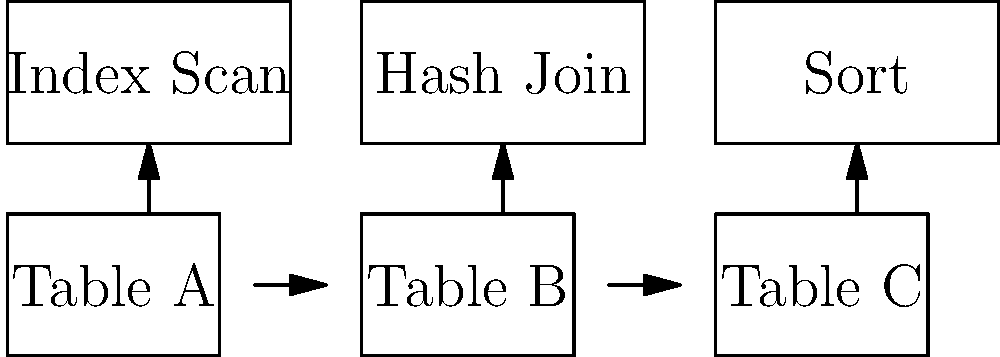Given the execution plan diagram above for a complex query involving three tables (A, B, and C), which step in the plan is likely to be the most resource-intensive and why? How would you optimize this query to improve its performance? To analyze and optimize the query based on the execution plan diagram, let's follow these steps:

1. Understand the execution plan:
   - Table A undergoes an Index Scan
   - Tables A and B are joined using a Hash Join
   - The result is then sorted

2. Identify the most resource-intensive step:
   The Hash Join is likely to be the most resource-intensive step because:
   a) It requires building a hash table in memory for one of the input tables
   b) It then probes the hash table for each row from the other table
   c) Hash Joins can consume significant memory and CPU resources, especially for large datasets

3. Optimization strategies:
   a) Improve indexing:
      - Ensure appropriate indexes are in place on join columns for Tables A and B
      - This can potentially change the Index Scan to a more efficient Index Seek
   
   b) Optimize the Hash Join:
      - Adjust database statistics to help the query optimizer choose the best join order
      - Consider using a different join algorithm (e.g., Merge Join) if data is already sorted
   
   c) Reduce data volume:
      - Add filters or predicates to reduce the number of rows processed before the join
      - Use column-based indexing if only specific columns are needed
   
   d) Materialized Views:
      - If this query is run frequently, consider creating a materialized view that pre-computes the join
   
   e) Partitioning:
      - If dealing with large tables, consider table partitioning to improve join performance

4. Query rewriting:
   - Rewrite the query to use EXISTS or IN clauses instead of joins where appropriate
   - Consider using CTEs (Common Table Expressions) to break down complex logic

5. Hardware considerations:
   - Ensure sufficient memory is available for hash table creation
   - Consider using SSDs for improved I/O performance

6. Monitoring and tuning:
   - Use database monitoring tools to identify resource bottlenecks
   - Adjust database parameters (e.g., work_mem in PostgreSQL) to optimize hash join performance

By applying these optimization techniques, you can potentially improve the query's performance by reducing the resource consumption of the Hash Join step and optimizing the overall execution plan.
Answer: Optimize Hash Join: improve indexing, adjust statistics, reduce data volume, consider materialized views or partitioning, and tune database parameters. 